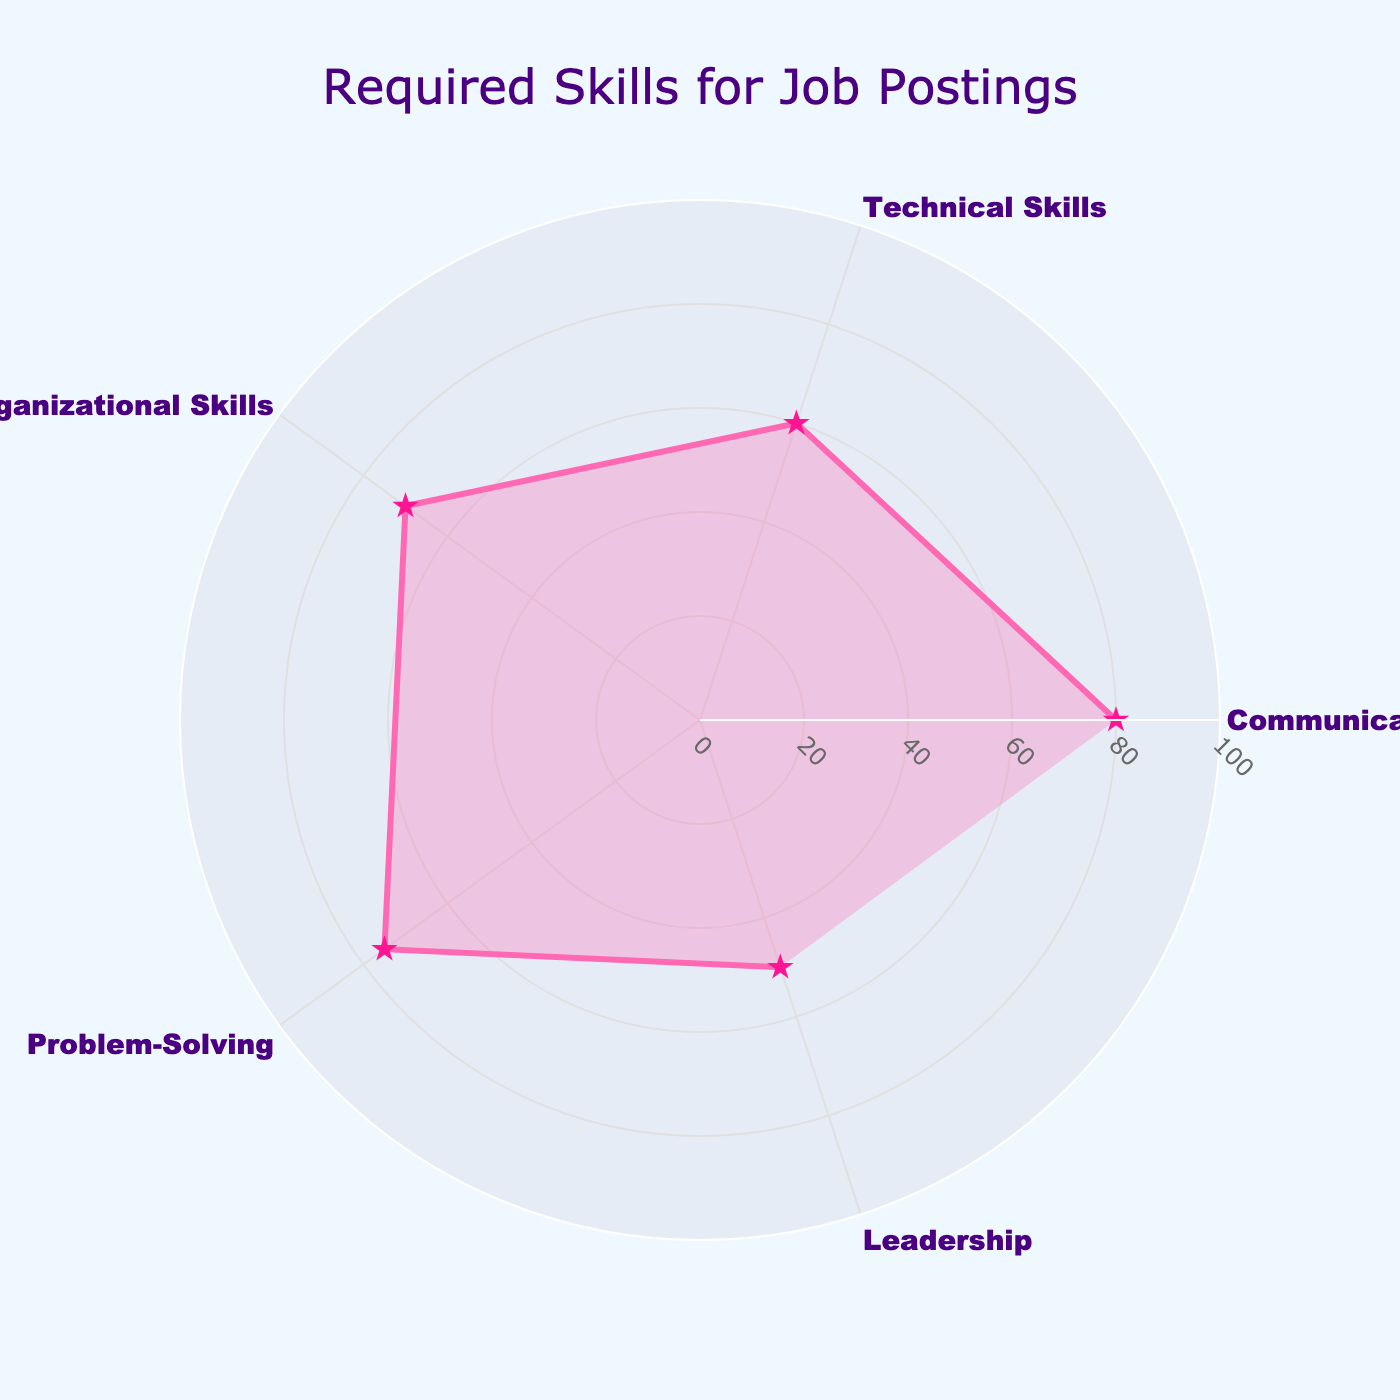What is the title of the radar chart? The title is displayed at the top of the radar chart. It can be read directly.
Answer: Required Skills for Job Postings How many job postings require communication skills? The radar chart shows the frequency for communication skills along one of its axes. The value can be directly read from the chart's axis.
Answer: 80 What is the frequency of job postings needing leadership skills compared to problem-solving skills? Locate the frequencies for leadership and problem-solving skills on their respective axes and compare them.
Answer: Leadership: 50, Problem-Solving: 75 Which skill is the least required based on the radar chart? Find the axis with the smallest value.
Answer: Leadership What is the average frequency of all required skills? Add the frequencies of all skills and divide by the number of skills. (80 + 60 + 70 + 75 + 50) / 5 = 335 / 5
Answer: 67 By how much do communication skills exceed technical skills in job postings? Subtract the frequency of technical skills from the frequency of communication skills. 80 - 60 = 20
Answer: 20 Are organizational skills or leadership skills required more often? Compare the frequencies for organizational skills and leadership skills. The higher value indicates which skill is required more often.
Answer: Organizational Skills What is the range of frequencies for the skills shown in the radar chart? Determine the difference between the highest frequency (for communication skills) and the lowest frequency (for leadership skills). 80 - 50 = 30
Answer: 30 What is the sum of the frequencies for communication skills and problem-solving skills? Add the frequencies for communication skills and problem-solving skills. 80 + 75 = 155
Answer: 155 Which two skills have the closest frequency values in job postings? Compare the frequency values of all pairs of skills to find the smallest difference. Organizational Skills (70) and Problem-Solving (75) have the smallest difference of 5.
Answer: Organizational Skills and Problem-Solving 